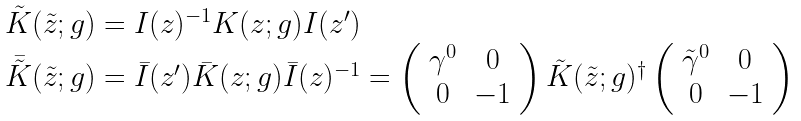<formula> <loc_0><loc_0><loc_500><loc_500>\begin{array} { l } { { \tilde { K } ( \tilde { z } ; g ) = I ( z ) ^ { - 1 } K ( z ; g ) I ( z ^ { \prime } ) } } \\ { { \bar { \tilde { K } } ( \tilde { z } ; g ) = \bar { I } ( z ^ { \prime } ) \bar { K } ( z ; g ) \bar { I } ( z ) ^ { - 1 } = \left ( \begin{array} { c c } { { \gamma ^ { 0 } } } & { 0 } \\ { 0 } & { - 1 } \end{array} \right ) \tilde { K } ( \tilde { z } ; g ) ^ { \dagger } \left ( \begin{array} { c c } { { \tilde { \gamma } ^ { 0 } } } & { 0 } \\ { 0 } & { - 1 } \end{array} \right ) } } \end{array}</formula> 